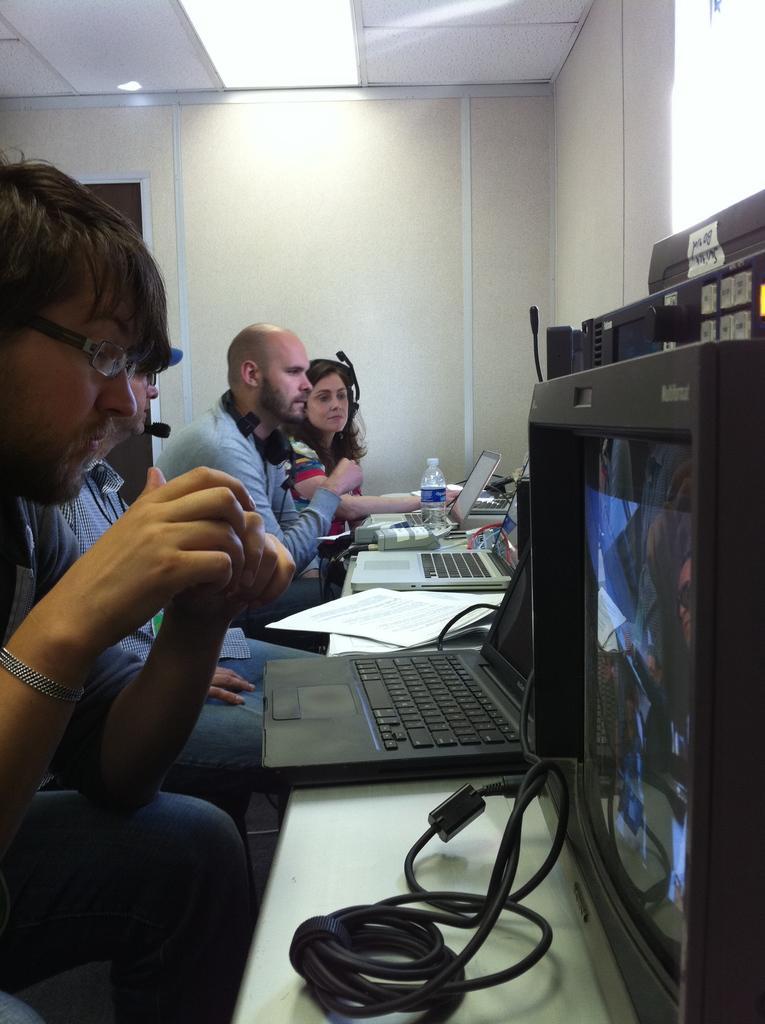Can you describe this image briefly? In the picture there are few men sat in front of table on which there are laptops and on the ceiling there are lights. 